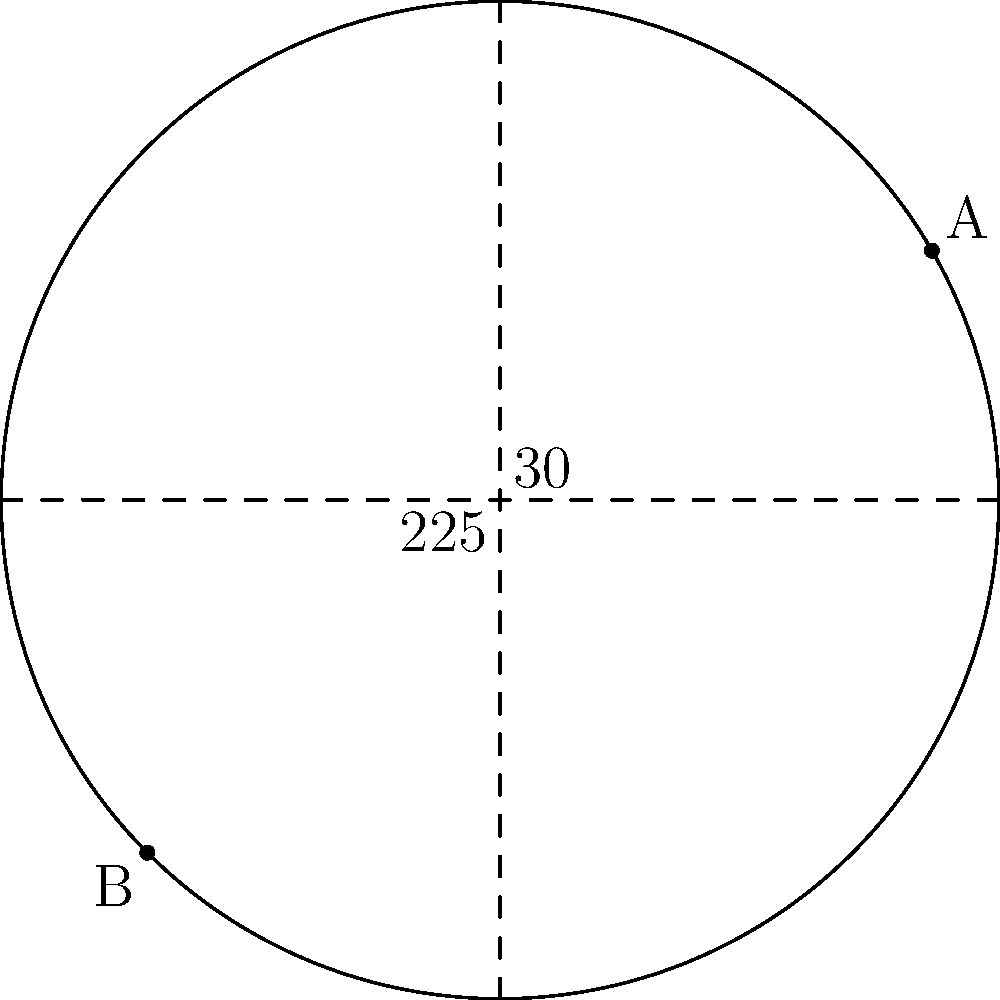You've discovered two ancestral locations on an old family map. The map uses a polar coordinate system with your hometown at the origin. Location A is at $(5, 30°)$ and location B is at $(5, 225°)$. What is the straight-line distance between these two locations? To find the distance between two points in polar coordinates, we can use the following steps:

1. Convert the polar coordinates to Cartesian coordinates:
   For A $(r_1, \theta_1) = (5, 30°)$:
   $x_1 = r_1 \cos(\theta_1) = 5 \cos(30°) = 5 \cdot \frac{\sqrt{3}}{2} = \frac{5\sqrt{3}}{2}$
   $y_1 = r_1 \sin(\theta_1) = 5 \sin(30°) = 5 \cdot \frac{1}{2} = \frac{5}{2}$

   For B $(r_2, \theta_2) = (5, 225°)$:
   $x_2 = r_2 \cos(\theta_2) = 5 \cos(225°) = 5 \cdot (-\frac{\sqrt{2}}{2}) = -\frac{5\sqrt{2}}{2}$
   $y_2 = r_2 \sin(\theta_2) = 5 \sin(225°) = 5 \cdot (-\frac{\sqrt{2}}{2}) = -\frac{5\sqrt{2}}{2}$

2. Use the distance formula in Cartesian coordinates:
   $d = \sqrt{(x_2-x_1)^2 + (y_2-y_1)^2}$

3. Substitute the values:
   $d = \sqrt{(-\frac{5\sqrt{2}}{2} - \frac{5\sqrt{3}}{2})^2 + (-\frac{5\sqrt{2}}{2} - \frac{5}{2})^2}$

4. Simplify:
   $d = \sqrt{(\frac{-5\sqrt{2}-5\sqrt{3}}{2})^2 + (\frac{-5\sqrt{2}-5}{2})^2}$
   $d = \sqrt{\frac{25(2+2\sqrt{6}+3)}{4} + \frac{25(2+2\sqrt{2}+1)}{4}}$
   $d = \sqrt{\frac{25(5+2\sqrt{6}+2\sqrt{2})}{4}}$
   $d = \frac{5\sqrt{5+2\sqrt{6}+2\sqrt{2}}}{2}$

5. This can be further simplified to:
   $d = 5\sqrt{2-\sqrt{2}}$
Answer: $5\sqrt{2-\sqrt{2}}$ 